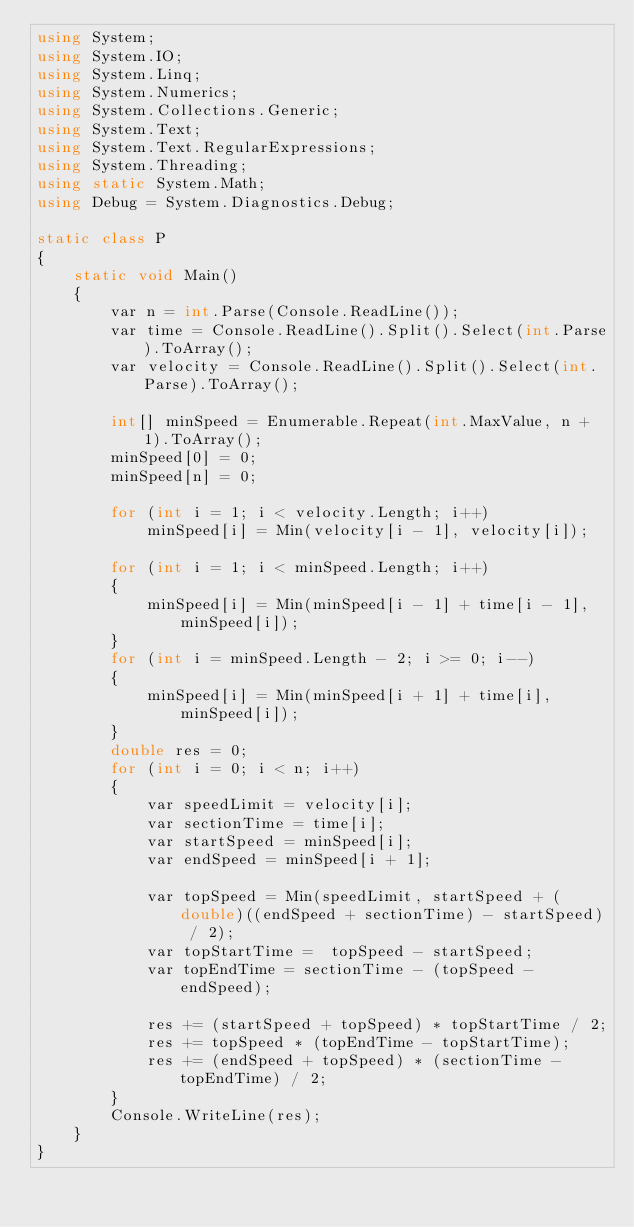Convert code to text. <code><loc_0><loc_0><loc_500><loc_500><_C#_>using System;
using System.IO;
using System.Linq;
using System.Numerics;
using System.Collections.Generic;
using System.Text;
using System.Text.RegularExpressions;
using System.Threading;
using static System.Math;
using Debug = System.Diagnostics.Debug;

static class P
{
    static void Main()
    {
        var n = int.Parse(Console.ReadLine());
        var time = Console.ReadLine().Split().Select(int.Parse).ToArray();
        var velocity = Console.ReadLine().Split().Select(int.Parse).ToArray();

        int[] minSpeed = Enumerable.Repeat(int.MaxValue, n + 1).ToArray();
        minSpeed[0] = 0;
        minSpeed[n] = 0;

        for (int i = 1; i < velocity.Length; i++)
            minSpeed[i] = Min(velocity[i - 1], velocity[i]);

        for (int i = 1; i < minSpeed.Length; i++)
        {
            minSpeed[i] = Min(minSpeed[i - 1] + time[i - 1], minSpeed[i]);
        }
        for (int i = minSpeed.Length - 2; i >= 0; i--)
        {
            minSpeed[i] = Min(minSpeed[i + 1] + time[i], minSpeed[i]);
        }
        double res = 0;
        for (int i = 0; i < n; i++)
        {
            var speedLimit = velocity[i];
            var sectionTime = time[i];
            var startSpeed = minSpeed[i];
            var endSpeed = minSpeed[i + 1];

            var topSpeed = Min(speedLimit, startSpeed + (double)((endSpeed + sectionTime) - startSpeed) / 2);
            var topStartTime =  topSpeed - startSpeed;
            var topEndTime = sectionTime - (topSpeed - endSpeed);

            res += (startSpeed + topSpeed) * topStartTime / 2;
            res += topSpeed * (topEndTime - topStartTime);
            res += (endSpeed + topSpeed) * (sectionTime - topEndTime) / 2;
        }
        Console.WriteLine(res);
    }
}
</code> 